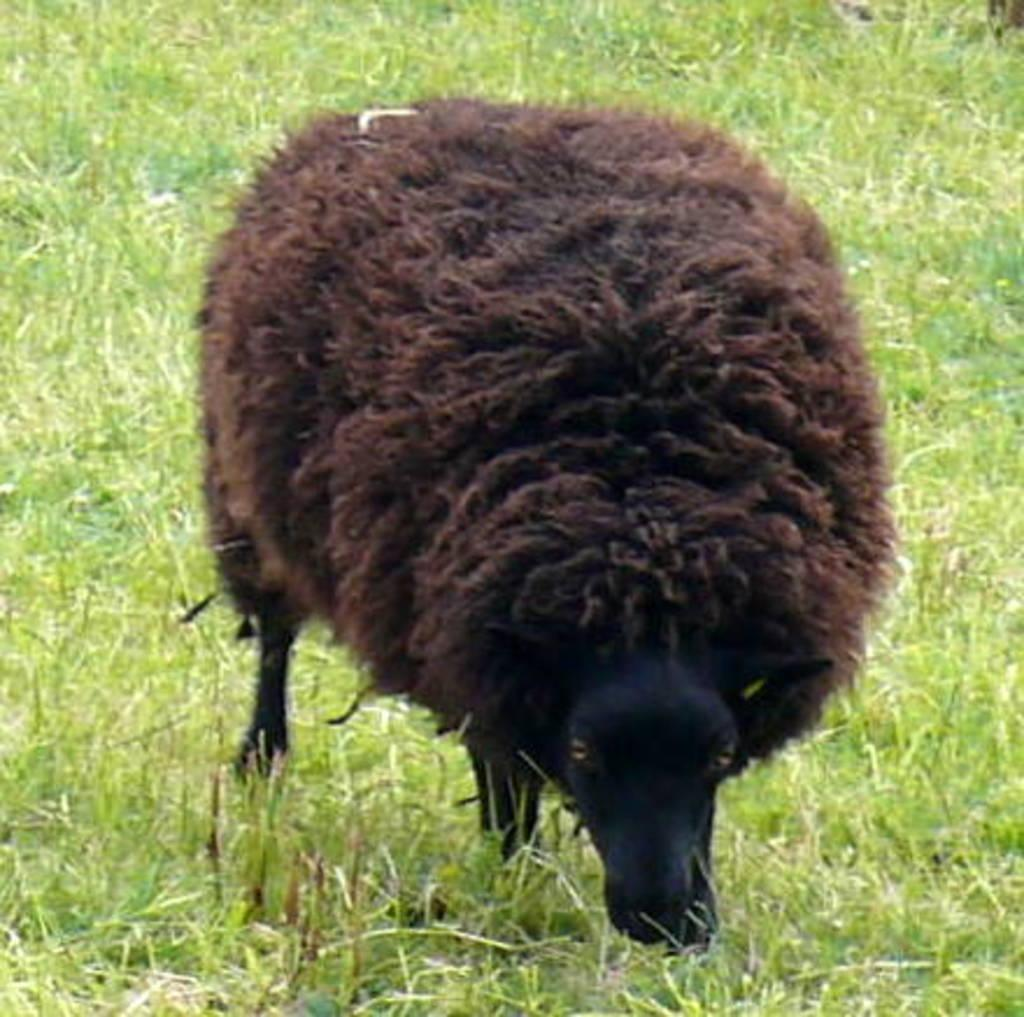What animal is present in the image? There is a sheep in the image. What is the sheep standing on? The sheep is standing on the grass. What type of skate is the sheep using to perform tricks in the image? There is no skate present in the image, and the sheep is not performing any tricks. 